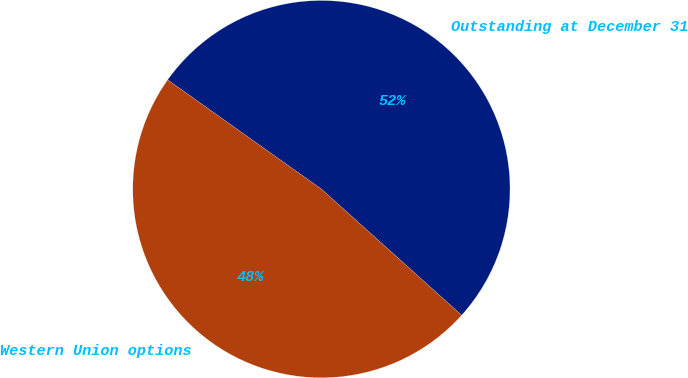Convert chart to OTSL. <chart><loc_0><loc_0><loc_500><loc_500><pie_chart><fcel>Outstanding at December 31<fcel>Western Union options<nl><fcel>51.82%<fcel>48.18%<nl></chart> 